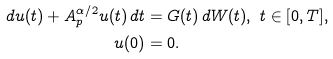Convert formula to latex. <formula><loc_0><loc_0><loc_500><loc_500>d u ( t ) + A _ { p } ^ { \alpha / 2 } u ( t ) \, d t & = G ( t ) \, d W ( t ) , \ t \in [ 0 , T ] , \\ u ( 0 ) & = 0 .</formula> 